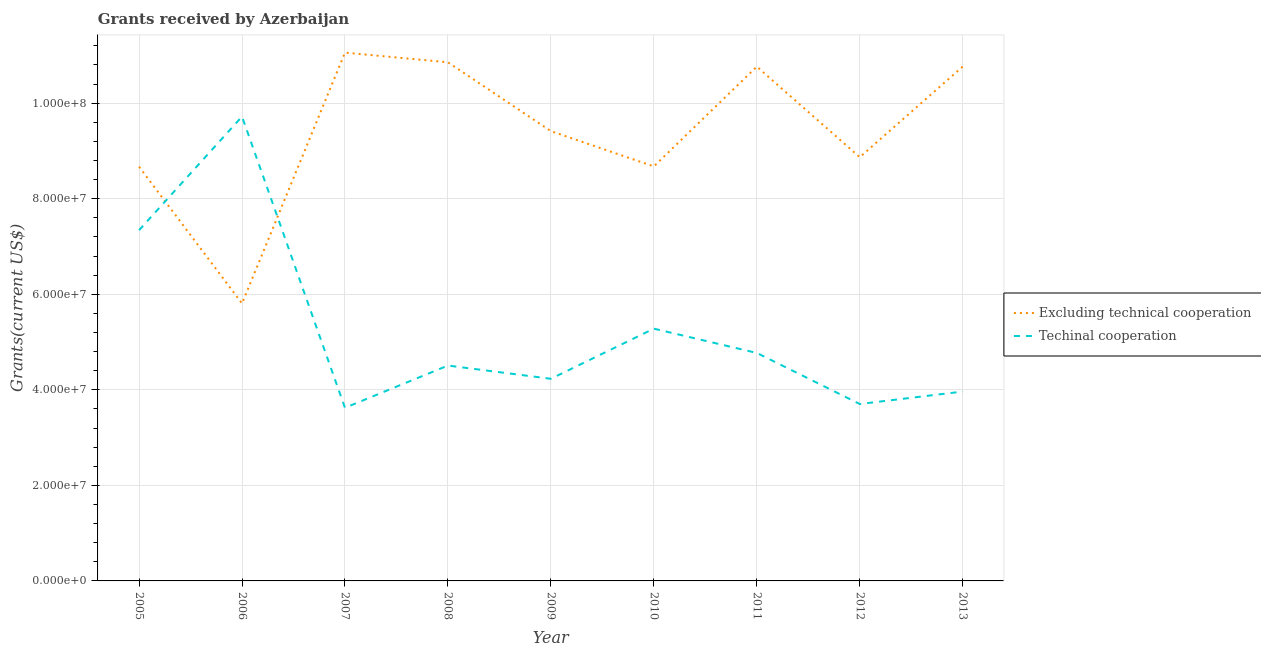Does the line corresponding to amount of grants received(excluding technical cooperation) intersect with the line corresponding to amount of grants received(including technical cooperation)?
Your answer should be compact. Yes. What is the amount of grants received(excluding technical cooperation) in 2011?
Offer a very short reply. 1.08e+08. Across all years, what is the maximum amount of grants received(excluding technical cooperation)?
Offer a very short reply. 1.11e+08. Across all years, what is the minimum amount of grants received(including technical cooperation)?
Your answer should be compact. 3.62e+07. In which year was the amount of grants received(including technical cooperation) maximum?
Offer a very short reply. 2006. In which year was the amount of grants received(excluding technical cooperation) minimum?
Your response must be concise. 2006. What is the total amount of grants received(excluding technical cooperation) in the graph?
Your answer should be very brief. 8.49e+08. What is the difference between the amount of grants received(including technical cooperation) in 2005 and that in 2009?
Offer a very short reply. 3.11e+07. What is the difference between the amount of grants received(excluding technical cooperation) in 2009 and the amount of grants received(including technical cooperation) in 2005?
Offer a terse response. 2.07e+07. What is the average amount of grants received(including technical cooperation) per year?
Give a very brief answer. 5.24e+07. In the year 2006, what is the difference between the amount of grants received(including technical cooperation) and amount of grants received(excluding technical cooperation)?
Provide a succinct answer. 3.91e+07. What is the ratio of the amount of grants received(excluding technical cooperation) in 2005 to that in 2006?
Provide a succinct answer. 1.49. Is the amount of grants received(including technical cooperation) in 2005 less than that in 2010?
Provide a short and direct response. No. What is the difference between the highest and the second highest amount of grants received(excluding technical cooperation)?
Make the answer very short. 2.02e+06. What is the difference between the highest and the lowest amount of grants received(excluding technical cooperation)?
Your answer should be very brief. 5.25e+07. Does the amount of grants received(including technical cooperation) monotonically increase over the years?
Provide a short and direct response. No. Is the amount of grants received(including technical cooperation) strictly greater than the amount of grants received(excluding technical cooperation) over the years?
Ensure brevity in your answer.  No. How many years are there in the graph?
Give a very brief answer. 9. What is the difference between two consecutive major ticks on the Y-axis?
Your response must be concise. 2.00e+07. Does the graph contain grids?
Provide a succinct answer. Yes. Where does the legend appear in the graph?
Your answer should be compact. Center right. What is the title of the graph?
Provide a short and direct response. Grants received by Azerbaijan. Does "Lowest 10% of population" appear as one of the legend labels in the graph?
Your response must be concise. No. What is the label or title of the Y-axis?
Your answer should be compact. Grants(current US$). What is the Grants(current US$) in Excluding technical cooperation in 2005?
Your answer should be compact. 8.67e+07. What is the Grants(current US$) of Techinal cooperation in 2005?
Offer a terse response. 7.34e+07. What is the Grants(current US$) of Excluding technical cooperation in 2006?
Offer a very short reply. 5.81e+07. What is the Grants(current US$) of Techinal cooperation in 2006?
Offer a terse response. 9.72e+07. What is the Grants(current US$) of Excluding technical cooperation in 2007?
Your answer should be compact. 1.11e+08. What is the Grants(current US$) in Techinal cooperation in 2007?
Provide a short and direct response. 3.62e+07. What is the Grants(current US$) in Excluding technical cooperation in 2008?
Provide a short and direct response. 1.09e+08. What is the Grants(current US$) of Techinal cooperation in 2008?
Your answer should be compact. 4.51e+07. What is the Grants(current US$) of Excluding technical cooperation in 2009?
Your response must be concise. 9.42e+07. What is the Grants(current US$) in Techinal cooperation in 2009?
Provide a succinct answer. 4.23e+07. What is the Grants(current US$) in Excluding technical cooperation in 2010?
Provide a succinct answer. 8.68e+07. What is the Grants(current US$) in Techinal cooperation in 2010?
Provide a short and direct response. 5.28e+07. What is the Grants(current US$) of Excluding technical cooperation in 2011?
Your answer should be compact. 1.08e+08. What is the Grants(current US$) of Techinal cooperation in 2011?
Your response must be concise. 4.77e+07. What is the Grants(current US$) of Excluding technical cooperation in 2012?
Offer a terse response. 8.87e+07. What is the Grants(current US$) in Techinal cooperation in 2012?
Make the answer very short. 3.70e+07. What is the Grants(current US$) of Excluding technical cooperation in 2013?
Make the answer very short. 1.08e+08. What is the Grants(current US$) of Techinal cooperation in 2013?
Your answer should be compact. 3.96e+07. Across all years, what is the maximum Grants(current US$) in Excluding technical cooperation?
Provide a succinct answer. 1.11e+08. Across all years, what is the maximum Grants(current US$) in Techinal cooperation?
Keep it short and to the point. 9.72e+07. Across all years, what is the minimum Grants(current US$) in Excluding technical cooperation?
Make the answer very short. 5.81e+07. Across all years, what is the minimum Grants(current US$) in Techinal cooperation?
Ensure brevity in your answer.  3.62e+07. What is the total Grants(current US$) in Excluding technical cooperation in the graph?
Your response must be concise. 8.49e+08. What is the total Grants(current US$) in Techinal cooperation in the graph?
Make the answer very short. 4.71e+08. What is the difference between the Grants(current US$) of Excluding technical cooperation in 2005 and that in 2006?
Your answer should be very brief. 2.86e+07. What is the difference between the Grants(current US$) of Techinal cooperation in 2005 and that in 2006?
Your answer should be compact. -2.38e+07. What is the difference between the Grants(current US$) of Excluding technical cooperation in 2005 and that in 2007?
Keep it short and to the point. -2.39e+07. What is the difference between the Grants(current US$) of Techinal cooperation in 2005 and that in 2007?
Your answer should be compact. 3.72e+07. What is the difference between the Grants(current US$) in Excluding technical cooperation in 2005 and that in 2008?
Ensure brevity in your answer.  -2.19e+07. What is the difference between the Grants(current US$) in Techinal cooperation in 2005 and that in 2008?
Make the answer very short. 2.83e+07. What is the difference between the Grants(current US$) of Excluding technical cooperation in 2005 and that in 2009?
Your answer should be very brief. -7.45e+06. What is the difference between the Grants(current US$) of Techinal cooperation in 2005 and that in 2009?
Your answer should be very brief. 3.11e+07. What is the difference between the Grants(current US$) in Excluding technical cooperation in 2005 and that in 2010?
Your answer should be very brief. -6.00e+04. What is the difference between the Grants(current US$) of Techinal cooperation in 2005 and that in 2010?
Your answer should be compact. 2.06e+07. What is the difference between the Grants(current US$) of Excluding technical cooperation in 2005 and that in 2011?
Your answer should be compact. -2.10e+07. What is the difference between the Grants(current US$) of Techinal cooperation in 2005 and that in 2011?
Your response must be concise. 2.57e+07. What is the difference between the Grants(current US$) of Excluding technical cooperation in 2005 and that in 2012?
Provide a succinct answer. -1.99e+06. What is the difference between the Grants(current US$) in Techinal cooperation in 2005 and that in 2012?
Ensure brevity in your answer.  3.64e+07. What is the difference between the Grants(current US$) of Excluding technical cooperation in 2005 and that in 2013?
Your answer should be very brief. -2.10e+07. What is the difference between the Grants(current US$) of Techinal cooperation in 2005 and that in 2013?
Keep it short and to the point. 3.38e+07. What is the difference between the Grants(current US$) of Excluding technical cooperation in 2006 and that in 2007?
Ensure brevity in your answer.  -5.25e+07. What is the difference between the Grants(current US$) in Techinal cooperation in 2006 and that in 2007?
Ensure brevity in your answer.  6.10e+07. What is the difference between the Grants(current US$) in Excluding technical cooperation in 2006 and that in 2008?
Offer a very short reply. -5.05e+07. What is the difference between the Grants(current US$) of Techinal cooperation in 2006 and that in 2008?
Offer a terse response. 5.21e+07. What is the difference between the Grants(current US$) in Excluding technical cooperation in 2006 and that in 2009?
Keep it short and to the point. -3.61e+07. What is the difference between the Grants(current US$) of Techinal cooperation in 2006 and that in 2009?
Provide a short and direct response. 5.49e+07. What is the difference between the Grants(current US$) in Excluding technical cooperation in 2006 and that in 2010?
Provide a short and direct response. -2.87e+07. What is the difference between the Grants(current US$) in Techinal cooperation in 2006 and that in 2010?
Offer a very short reply. 4.44e+07. What is the difference between the Grants(current US$) of Excluding technical cooperation in 2006 and that in 2011?
Ensure brevity in your answer.  -4.96e+07. What is the difference between the Grants(current US$) in Techinal cooperation in 2006 and that in 2011?
Your answer should be compact. 4.95e+07. What is the difference between the Grants(current US$) of Excluding technical cooperation in 2006 and that in 2012?
Offer a very short reply. -3.06e+07. What is the difference between the Grants(current US$) in Techinal cooperation in 2006 and that in 2012?
Offer a very short reply. 6.02e+07. What is the difference between the Grants(current US$) in Excluding technical cooperation in 2006 and that in 2013?
Make the answer very short. -4.96e+07. What is the difference between the Grants(current US$) of Techinal cooperation in 2006 and that in 2013?
Offer a terse response. 5.76e+07. What is the difference between the Grants(current US$) in Excluding technical cooperation in 2007 and that in 2008?
Provide a succinct answer. 2.02e+06. What is the difference between the Grants(current US$) of Techinal cooperation in 2007 and that in 2008?
Offer a very short reply. -8.84e+06. What is the difference between the Grants(current US$) in Excluding technical cooperation in 2007 and that in 2009?
Your answer should be very brief. 1.64e+07. What is the difference between the Grants(current US$) in Techinal cooperation in 2007 and that in 2009?
Ensure brevity in your answer.  -6.07e+06. What is the difference between the Grants(current US$) in Excluding technical cooperation in 2007 and that in 2010?
Your response must be concise. 2.38e+07. What is the difference between the Grants(current US$) in Techinal cooperation in 2007 and that in 2010?
Your answer should be compact. -1.66e+07. What is the difference between the Grants(current US$) of Excluding technical cooperation in 2007 and that in 2011?
Provide a short and direct response. 2.92e+06. What is the difference between the Grants(current US$) in Techinal cooperation in 2007 and that in 2011?
Keep it short and to the point. -1.15e+07. What is the difference between the Grants(current US$) in Excluding technical cooperation in 2007 and that in 2012?
Provide a succinct answer. 2.19e+07. What is the difference between the Grants(current US$) of Techinal cooperation in 2007 and that in 2012?
Your answer should be very brief. -7.90e+05. What is the difference between the Grants(current US$) in Excluding technical cooperation in 2007 and that in 2013?
Make the answer very short. 2.92e+06. What is the difference between the Grants(current US$) in Techinal cooperation in 2007 and that in 2013?
Keep it short and to the point. -3.40e+06. What is the difference between the Grants(current US$) in Excluding technical cooperation in 2008 and that in 2009?
Your response must be concise. 1.44e+07. What is the difference between the Grants(current US$) in Techinal cooperation in 2008 and that in 2009?
Offer a very short reply. 2.77e+06. What is the difference between the Grants(current US$) in Excluding technical cooperation in 2008 and that in 2010?
Offer a very short reply. 2.18e+07. What is the difference between the Grants(current US$) in Techinal cooperation in 2008 and that in 2010?
Offer a very short reply. -7.72e+06. What is the difference between the Grants(current US$) of Techinal cooperation in 2008 and that in 2011?
Offer a very short reply. -2.64e+06. What is the difference between the Grants(current US$) in Excluding technical cooperation in 2008 and that in 2012?
Provide a short and direct response. 1.99e+07. What is the difference between the Grants(current US$) in Techinal cooperation in 2008 and that in 2012?
Your answer should be compact. 8.05e+06. What is the difference between the Grants(current US$) of Techinal cooperation in 2008 and that in 2013?
Give a very brief answer. 5.44e+06. What is the difference between the Grants(current US$) in Excluding technical cooperation in 2009 and that in 2010?
Provide a succinct answer. 7.39e+06. What is the difference between the Grants(current US$) in Techinal cooperation in 2009 and that in 2010?
Your answer should be very brief. -1.05e+07. What is the difference between the Grants(current US$) in Excluding technical cooperation in 2009 and that in 2011?
Provide a short and direct response. -1.35e+07. What is the difference between the Grants(current US$) in Techinal cooperation in 2009 and that in 2011?
Offer a terse response. -5.41e+06. What is the difference between the Grants(current US$) of Excluding technical cooperation in 2009 and that in 2012?
Ensure brevity in your answer.  5.46e+06. What is the difference between the Grants(current US$) in Techinal cooperation in 2009 and that in 2012?
Your answer should be compact. 5.28e+06. What is the difference between the Grants(current US$) in Excluding technical cooperation in 2009 and that in 2013?
Ensure brevity in your answer.  -1.35e+07. What is the difference between the Grants(current US$) in Techinal cooperation in 2009 and that in 2013?
Offer a terse response. 2.67e+06. What is the difference between the Grants(current US$) in Excluding technical cooperation in 2010 and that in 2011?
Ensure brevity in your answer.  -2.09e+07. What is the difference between the Grants(current US$) in Techinal cooperation in 2010 and that in 2011?
Provide a succinct answer. 5.08e+06. What is the difference between the Grants(current US$) of Excluding technical cooperation in 2010 and that in 2012?
Your answer should be compact. -1.93e+06. What is the difference between the Grants(current US$) of Techinal cooperation in 2010 and that in 2012?
Make the answer very short. 1.58e+07. What is the difference between the Grants(current US$) of Excluding technical cooperation in 2010 and that in 2013?
Provide a short and direct response. -2.09e+07. What is the difference between the Grants(current US$) of Techinal cooperation in 2010 and that in 2013?
Your answer should be compact. 1.32e+07. What is the difference between the Grants(current US$) in Excluding technical cooperation in 2011 and that in 2012?
Your answer should be compact. 1.90e+07. What is the difference between the Grants(current US$) of Techinal cooperation in 2011 and that in 2012?
Keep it short and to the point. 1.07e+07. What is the difference between the Grants(current US$) of Techinal cooperation in 2011 and that in 2013?
Provide a succinct answer. 8.08e+06. What is the difference between the Grants(current US$) of Excluding technical cooperation in 2012 and that in 2013?
Give a very brief answer. -1.90e+07. What is the difference between the Grants(current US$) in Techinal cooperation in 2012 and that in 2013?
Your response must be concise. -2.61e+06. What is the difference between the Grants(current US$) of Excluding technical cooperation in 2005 and the Grants(current US$) of Techinal cooperation in 2006?
Make the answer very short. -1.05e+07. What is the difference between the Grants(current US$) of Excluding technical cooperation in 2005 and the Grants(current US$) of Techinal cooperation in 2007?
Your answer should be compact. 5.05e+07. What is the difference between the Grants(current US$) of Excluding technical cooperation in 2005 and the Grants(current US$) of Techinal cooperation in 2008?
Give a very brief answer. 4.16e+07. What is the difference between the Grants(current US$) of Excluding technical cooperation in 2005 and the Grants(current US$) of Techinal cooperation in 2009?
Offer a terse response. 4.44e+07. What is the difference between the Grants(current US$) in Excluding technical cooperation in 2005 and the Grants(current US$) in Techinal cooperation in 2010?
Offer a very short reply. 3.39e+07. What is the difference between the Grants(current US$) of Excluding technical cooperation in 2005 and the Grants(current US$) of Techinal cooperation in 2011?
Ensure brevity in your answer.  3.90e+07. What is the difference between the Grants(current US$) in Excluding technical cooperation in 2005 and the Grants(current US$) in Techinal cooperation in 2012?
Provide a succinct answer. 4.97e+07. What is the difference between the Grants(current US$) of Excluding technical cooperation in 2005 and the Grants(current US$) of Techinal cooperation in 2013?
Your answer should be very brief. 4.71e+07. What is the difference between the Grants(current US$) in Excluding technical cooperation in 2006 and the Grants(current US$) in Techinal cooperation in 2007?
Keep it short and to the point. 2.18e+07. What is the difference between the Grants(current US$) in Excluding technical cooperation in 2006 and the Grants(current US$) in Techinal cooperation in 2008?
Your answer should be compact. 1.30e+07. What is the difference between the Grants(current US$) in Excluding technical cooperation in 2006 and the Grants(current US$) in Techinal cooperation in 2009?
Ensure brevity in your answer.  1.58e+07. What is the difference between the Grants(current US$) in Excluding technical cooperation in 2006 and the Grants(current US$) in Techinal cooperation in 2010?
Your answer should be compact. 5.28e+06. What is the difference between the Grants(current US$) of Excluding technical cooperation in 2006 and the Grants(current US$) of Techinal cooperation in 2011?
Your response must be concise. 1.04e+07. What is the difference between the Grants(current US$) in Excluding technical cooperation in 2006 and the Grants(current US$) in Techinal cooperation in 2012?
Your answer should be very brief. 2.10e+07. What is the difference between the Grants(current US$) in Excluding technical cooperation in 2006 and the Grants(current US$) in Techinal cooperation in 2013?
Provide a short and direct response. 1.84e+07. What is the difference between the Grants(current US$) of Excluding technical cooperation in 2007 and the Grants(current US$) of Techinal cooperation in 2008?
Your response must be concise. 6.55e+07. What is the difference between the Grants(current US$) in Excluding technical cooperation in 2007 and the Grants(current US$) in Techinal cooperation in 2009?
Keep it short and to the point. 6.83e+07. What is the difference between the Grants(current US$) of Excluding technical cooperation in 2007 and the Grants(current US$) of Techinal cooperation in 2010?
Give a very brief answer. 5.78e+07. What is the difference between the Grants(current US$) in Excluding technical cooperation in 2007 and the Grants(current US$) in Techinal cooperation in 2011?
Provide a succinct answer. 6.29e+07. What is the difference between the Grants(current US$) in Excluding technical cooperation in 2007 and the Grants(current US$) in Techinal cooperation in 2012?
Your answer should be compact. 7.36e+07. What is the difference between the Grants(current US$) of Excluding technical cooperation in 2007 and the Grants(current US$) of Techinal cooperation in 2013?
Ensure brevity in your answer.  7.09e+07. What is the difference between the Grants(current US$) in Excluding technical cooperation in 2008 and the Grants(current US$) in Techinal cooperation in 2009?
Your answer should be compact. 6.62e+07. What is the difference between the Grants(current US$) of Excluding technical cooperation in 2008 and the Grants(current US$) of Techinal cooperation in 2010?
Provide a short and direct response. 5.58e+07. What is the difference between the Grants(current US$) of Excluding technical cooperation in 2008 and the Grants(current US$) of Techinal cooperation in 2011?
Your answer should be compact. 6.08e+07. What is the difference between the Grants(current US$) of Excluding technical cooperation in 2008 and the Grants(current US$) of Techinal cooperation in 2012?
Provide a succinct answer. 7.15e+07. What is the difference between the Grants(current US$) in Excluding technical cooperation in 2008 and the Grants(current US$) in Techinal cooperation in 2013?
Provide a short and direct response. 6.89e+07. What is the difference between the Grants(current US$) in Excluding technical cooperation in 2009 and the Grants(current US$) in Techinal cooperation in 2010?
Offer a very short reply. 4.14e+07. What is the difference between the Grants(current US$) of Excluding technical cooperation in 2009 and the Grants(current US$) of Techinal cooperation in 2011?
Make the answer very short. 4.64e+07. What is the difference between the Grants(current US$) in Excluding technical cooperation in 2009 and the Grants(current US$) in Techinal cooperation in 2012?
Your answer should be very brief. 5.71e+07. What is the difference between the Grants(current US$) of Excluding technical cooperation in 2009 and the Grants(current US$) of Techinal cooperation in 2013?
Your answer should be very brief. 5.45e+07. What is the difference between the Grants(current US$) of Excluding technical cooperation in 2010 and the Grants(current US$) of Techinal cooperation in 2011?
Provide a succinct answer. 3.90e+07. What is the difference between the Grants(current US$) of Excluding technical cooperation in 2010 and the Grants(current US$) of Techinal cooperation in 2012?
Your response must be concise. 4.97e+07. What is the difference between the Grants(current US$) of Excluding technical cooperation in 2010 and the Grants(current US$) of Techinal cooperation in 2013?
Offer a terse response. 4.71e+07. What is the difference between the Grants(current US$) of Excluding technical cooperation in 2011 and the Grants(current US$) of Techinal cooperation in 2012?
Give a very brief answer. 7.06e+07. What is the difference between the Grants(current US$) in Excluding technical cooperation in 2011 and the Grants(current US$) in Techinal cooperation in 2013?
Offer a terse response. 6.80e+07. What is the difference between the Grants(current US$) of Excluding technical cooperation in 2012 and the Grants(current US$) of Techinal cooperation in 2013?
Make the answer very short. 4.90e+07. What is the average Grants(current US$) of Excluding technical cooperation per year?
Your answer should be compact. 9.43e+07. What is the average Grants(current US$) in Techinal cooperation per year?
Make the answer very short. 5.24e+07. In the year 2005, what is the difference between the Grants(current US$) of Excluding technical cooperation and Grants(current US$) of Techinal cooperation?
Offer a terse response. 1.33e+07. In the year 2006, what is the difference between the Grants(current US$) in Excluding technical cooperation and Grants(current US$) in Techinal cooperation?
Your answer should be very brief. -3.91e+07. In the year 2007, what is the difference between the Grants(current US$) of Excluding technical cooperation and Grants(current US$) of Techinal cooperation?
Offer a very short reply. 7.43e+07. In the year 2008, what is the difference between the Grants(current US$) in Excluding technical cooperation and Grants(current US$) in Techinal cooperation?
Provide a short and direct response. 6.35e+07. In the year 2009, what is the difference between the Grants(current US$) of Excluding technical cooperation and Grants(current US$) of Techinal cooperation?
Offer a terse response. 5.18e+07. In the year 2010, what is the difference between the Grants(current US$) of Excluding technical cooperation and Grants(current US$) of Techinal cooperation?
Your answer should be very brief. 3.40e+07. In the year 2011, what is the difference between the Grants(current US$) in Excluding technical cooperation and Grants(current US$) in Techinal cooperation?
Provide a succinct answer. 5.99e+07. In the year 2012, what is the difference between the Grants(current US$) in Excluding technical cooperation and Grants(current US$) in Techinal cooperation?
Give a very brief answer. 5.17e+07. In the year 2013, what is the difference between the Grants(current US$) of Excluding technical cooperation and Grants(current US$) of Techinal cooperation?
Give a very brief answer. 6.80e+07. What is the ratio of the Grants(current US$) of Excluding technical cooperation in 2005 to that in 2006?
Offer a terse response. 1.49. What is the ratio of the Grants(current US$) of Techinal cooperation in 2005 to that in 2006?
Provide a succinct answer. 0.76. What is the ratio of the Grants(current US$) in Excluding technical cooperation in 2005 to that in 2007?
Keep it short and to the point. 0.78. What is the ratio of the Grants(current US$) of Techinal cooperation in 2005 to that in 2007?
Offer a terse response. 2.03. What is the ratio of the Grants(current US$) in Excluding technical cooperation in 2005 to that in 2008?
Provide a succinct answer. 0.8. What is the ratio of the Grants(current US$) of Techinal cooperation in 2005 to that in 2008?
Offer a terse response. 1.63. What is the ratio of the Grants(current US$) in Excluding technical cooperation in 2005 to that in 2009?
Ensure brevity in your answer.  0.92. What is the ratio of the Grants(current US$) of Techinal cooperation in 2005 to that in 2009?
Give a very brief answer. 1.74. What is the ratio of the Grants(current US$) of Techinal cooperation in 2005 to that in 2010?
Keep it short and to the point. 1.39. What is the ratio of the Grants(current US$) in Excluding technical cooperation in 2005 to that in 2011?
Offer a very short reply. 0.81. What is the ratio of the Grants(current US$) of Techinal cooperation in 2005 to that in 2011?
Your response must be concise. 1.54. What is the ratio of the Grants(current US$) of Excluding technical cooperation in 2005 to that in 2012?
Offer a terse response. 0.98. What is the ratio of the Grants(current US$) in Techinal cooperation in 2005 to that in 2012?
Ensure brevity in your answer.  1.98. What is the ratio of the Grants(current US$) of Excluding technical cooperation in 2005 to that in 2013?
Offer a terse response. 0.81. What is the ratio of the Grants(current US$) of Techinal cooperation in 2005 to that in 2013?
Provide a succinct answer. 1.85. What is the ratio of the Grants(current US$) in Excluding technical cooperation in 2006 to that in 2007?
Offer a very short reply. 0.53. What is the ratio of the Grants(current US$) of Techinal cooperation in 2006 to that in 2007?
Provide a short and direct response. 2.68. What is the ratio of the Grants(current US$) of Excluding technical cooperation in 2006 to that in 2008?
Offer a terse response. 0.54. What is the ratio of the Grants(current US$) of Techinal cooperation in 2006 to that in 2008?
Give a very brief answer. 2.16. What is the ratio of the Grants(current US$) in Excluding technical cooperation in 2006 to that in 2009?
Offer a terse response. 0.62. What is the ratio of the Grants(current US$) of Techinal cooperation in 2006 to that in 2009?
Offer a very short reply. 2.3. What is the ratio of the Grants(current US$) in Excluding technical cooperation in 2006 to that in 2010?
Provide a short and direct response. 0.67. What is the ratio of the Grants(current US$) of Techinal cooperation in 2006 to that in 2010?
Your answer should be compact. 1.84. What is the ratio of the Grants(current US$) in Excluding technical cooperation in 2006 to that in 2011?
Your response must be concise. 0.54. What is the ratio of the Grants(current US$) of Techinal cooperation in 2006 to that in 2011?
Offer a terse response. 2.04. What is the ratio of the Grants(current US$) in Excluding technical cooperation in 2006 to that in 2012?
Provide a short and direct response. 0.65. What is the ratio of the Grants(current US$) of Techinal cooperation in 2006 to that in 2012?
Make the answer very short. 2.62. What is the ratio of the Grants(current US$) in Excluding technical cooperation in 2006 to that in 2013?
Give a very brief answer. 0.54. What is the ratio of the Grants(current US$) of Techinal cooperation in 2006 to that in 2013?
Offer a very short reply. 2.45. What is the ratio of the Grants(current US$) of Excluding technical cooperation in 2007 to that in 2008?
Keep it short and to the point. 1.02. What is the ratio of the Grants(current US$) of Techinal cooperation in 2007 to that in 2008?
Make the answer very short. 0.8. What is the ratio of the Grants(current US$) of Excluding technical cooperation in 2007 to that in 2009?
Make the answer very short. 1.17. What is the ratio of the Grants(current US$) in Techinal cooperation in 2007 to that in 2009?
Provide a succinct answer. 0.86. What is the ratio of the Grants(current US$) in Excluding technical cooperation in 2007 to that in 2010?
Your answer should be compact. 1.27. What is the ratio of the Grants(current US$) of Techinal cooperation in 2007 to that in 2010?
Offer a very short reply. 0.69. What is the ratio of the Grants(current US$) in Excluding technical cooperation in 2007 to that in 2011?
Make the answer very short. 1.03. What is the ratio of the Grants(current US$) of Techinal cooperation in 2007 to that in 2011?
Give a very brief answer. 0.76. What is the ratio of the Grants(current US$) of Excluding technical cooperation in 2007 to that in 2012?
Give a very brief answer. 1.25. What is the ratio of the Grants(current US$) in Techinal cooperation in 2007 to that in 2012?
Offer a very short reply. 0.98. What is the ratio of the Grants(current US$) of Excluding technical cooperation in 2007 to that in 2013?
Your response must be concise. 1.03. What is the ratio of the Grants(current US$) in Techinal cooperation in 2007 to that in 2013?
Make the answer very short. 0.91. What is the ratio of the Grants(current US$) of Excluding technical cooperation in 2008 to that in 2009?
Provide a succinct answer. 1.15. What is the ratio of the Grants(current US$) of Techinal cooperation in 2008 to that in 2009?
Provide a short and direct response. 1.07. What is the ratio of the Grants(current US$) in Excluding technical cooperation in 2008 to that in 2010?
Provide a short and direct response. 1.25. What is the ratio of the Grants(current US$) of Techinal cooperation in 2008 to that in 2010?
Offer a very short reply. 0.85. What is the ratio of the Grants(current US$) of Excluding technical cooperation in 2008 to that in 2011?
Your answer should be compact. 1.01. What is the ratio of the Grants(current US$) in Techinal cooperation in 2008 to that in 2011?
Offer a very short reply. 0.94. What is the ratio of the Grants(current US$) in Excluding technical cooperation in 2008 to that in 2012?
Your answer should be compact. 1.22. What is the ratio of the Grants(current US$) of Techinal cooperation in 2008 to that in 2012?
Your answer should be compact. 1.22. What is the ratio of the Grants(current US$) in Excluding technical cooperation in 2008 to that in 2013?
Give a very brief answer. 1.01. What is the ratio of the Grants(current US$) in Techinal cooperation in 2008 to that in 2013?
Keep it short and to the point. 1.14. What is the ratio of the Grants(current US$) of Excluding technical cooperation in 2009 to that in 2010?
Ensure brevity in your answer.  1.09. What is the ratio of the Grants(current US$) of Techinal cooperation in 2009 to that in 2010?
Ensure brevity in your answer.  0.8. What is the ratio of the Grants(current US$) of Excluding technical cooperation in 2009 to that in 2011?
Offer a very short reply. 0.87. What is the ratio of the Grants(current US$) in Techinal cooperation in 2009 to that in 2011?
Provide a succinct answer. 0.89. What is the ratio of the Grants(current US$) of Excluding technical cooperation in 2009 to that in 2012?
Provide a succinct answer. 1.06. What is the ratio of the Grants(current US$) of Techinal cooperation in 2009 to that in 2012?
Your answer should be compact. 1.14. What is the ratio of the Grants(current US$) of Excluding technical cooperation in 2009 to that in 2013?
Ensure brevity in your answer.  0.87. What is the ratio of the Grants(current US$) in Techinal cooperation in 2009 to that in 2013?
Keep it short and to the point. 1.07. What is the ratio of the Grants(current US$) of Excluding technical cooperation in 2010 to that in 2011?
Your answer should be very brief. 0.81. What is the ratio of the Grants(current US$) in Techinal cooperation in 2010 to that in 2011?
Ensure brevity in your answer.  1.11. What is the ratio of the Grants(current US$) in Excluding technical cooperation in 2010 to that in 2012?
Your answer should be compact. 0.98. What is the ratio of the Grants(current US$) in Techinal cooperation in 2010 to that in 2012?
Your response must be concise. 1.43. What is the ratio of the Grants(current US$) of Excluding technical cooperation in 2010 to that in 2013?
Make the answer very short. 0.81. What is the ratio of the Grants(current US$) in Techinal cooperation in 2010 to that in 2013?
Offer a terse response. 1.33. What is the ratio of the Grants(current US$) of Excluding technical cooperation in 2011 to that in 2012?
Provide a succinct answer. 1.21. What is the ratio of the Grants(current US$) in Techinal cooperation in 2011 to that in 2012?
Your answer should be very brief. 1.29. What is the ratio of the Grants(current US$) of Excluding technical cooperation in 2011 to that in 2013?
Your response must be concise. 1. What is the ratio of the Grants(current US$) of Techinal cooperation in 2011 to that in 2013?
Your answer should be compact. 1.2. What is the ratio of the Grants(current US$) of Excluding technical cooperation in 2012 to that in 2013?
Your answer should be compact. 0.82. What is the ratio of the Grants(current US$) in Techinal cooperation in 2012 to that in 2013?
Ensure brevity in your answer.  0.93. What is the difference between the highest and the second highest Grants(current US$) of Excluding technical cooperation?
Ensure brevity in your answer.  2.02e+06. What is the difference between the highest and the second highest Grants(current US$) in Techinal cooperation?
Provide a succinct answer. 2.38e+07. What is the difference between the highest and the lowest Grants(current US$) in Excluding technical cooperation?
Your response must be concise. 5.25e+07. What is the difference between the highest and the lowest Grants(current US$) in Techinal cooperation?
Offer a terse response. 6.10e+07. 